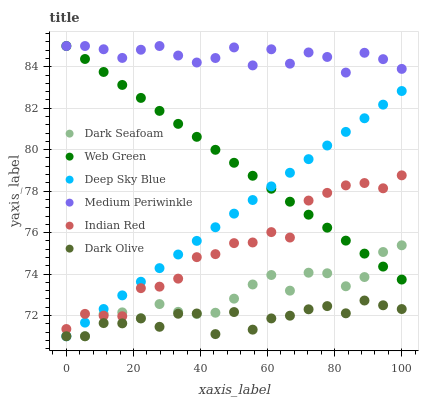Does Dark Olive have the minimum area under the curve?
Answer yes or no. Yes. Does Medium Periwinkle have the maximum area under the curve?
Answer yes or no. Yes. Does Medium Periwinkle have the minimum area under the curve?
Answer yes or no. No. Does Dark Olive have the maximum area under the curve?
Answer yes or no. No. Is Deep Sky Blue the smoothest?
Answer yes or no. Yes. Is Dark Olive the roughest?
Answer yes or no. Yes. Is Medium Periwinkle the smoothest?
Answer yes or no. No. Is Medium Periwinkle the roughest?
Answer yes or no. No. Does Deep Sky Blue have the lowest value?
Answer yes or no. Yes. Does Medium Periwinkle have the lowest value?
Answer yes or no. No. Does Web Green have the highest value?
Answer yes or no. Yes. Does Dark Olive have the highest value?
Answer yes or no. No. Is Dark Olive less than Medium Periwinkle?
Answer yes or no. Yes. Is Indian Red greater than Dark Olive?
Answer yes or no. Yes. Does Web Green intersect Deep Sky Blue?
Answer yes or no. Yes. Is Web Green less than Deep Sky Blue?
Answer yes or no. No. Is Web Green greater than Deep Sky Blue?
Answer yes or no. No. Does Dark Olive intersect Medium Periwinkle?
Answer yes or no. No. 